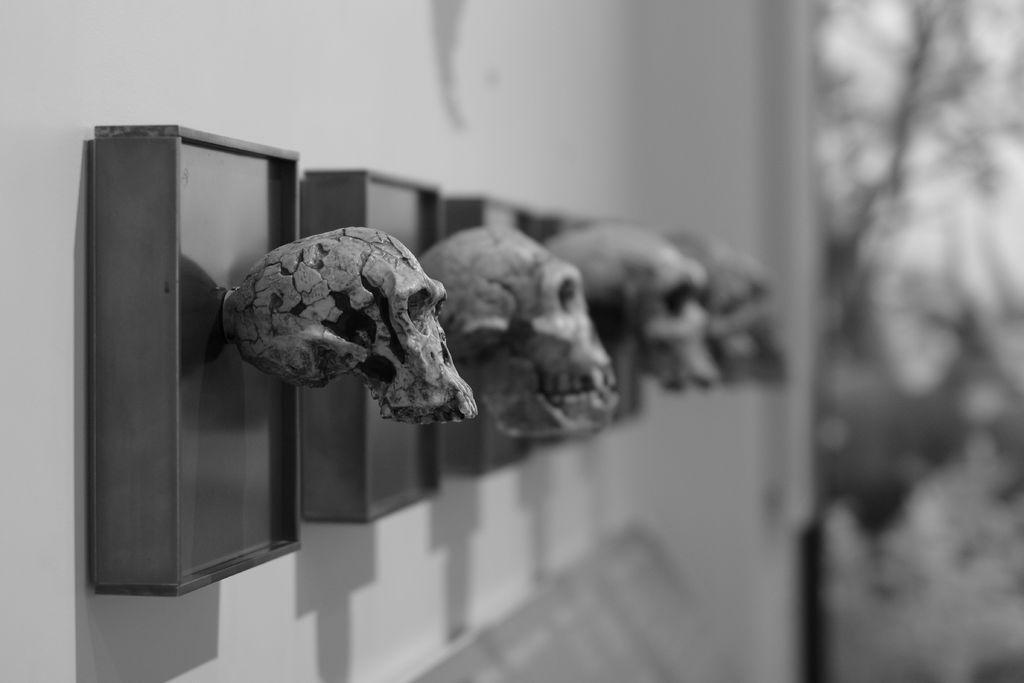Can you describe this image briefly? In this image we can see there are boxes with skull attached to the wall and blur background. 